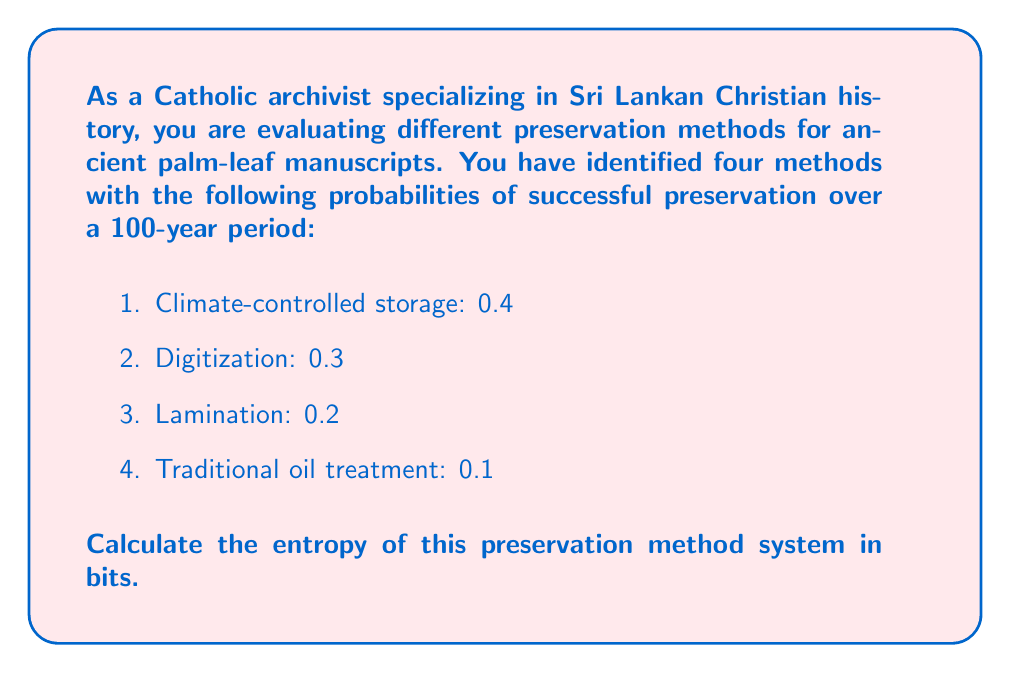Solve this math problem. To calculate the entropy of this system, we'll use the formula for Shannon entropy:

$$H = -\sum_{i=1}^n p_i \log_2(p_i)$$

Where:
- $H$ is the entropy in bits
- $p_i$ is the probability of each outcome
- $n$ is the number of possible outcomes

Let's calculate each term:

1. $-0.4 \log_2(0.4) = 0.528321$
2. $-0.3 \log_2(0.3) = 0.521126$
3. $-0.2 \log_2(0.2) = 0.464386$
4. $-0.1 \log_2(0.1) = 0.332193$

Now, sum all these terms:

$$H = 0.528321 + 0.521126 + 0.464386 + 0.332193$$

$$H = 1.846026$$

Therefore, the entropy of this preservation method system is approximately 1.846026 bits.
Answer: 1.846026 bits 